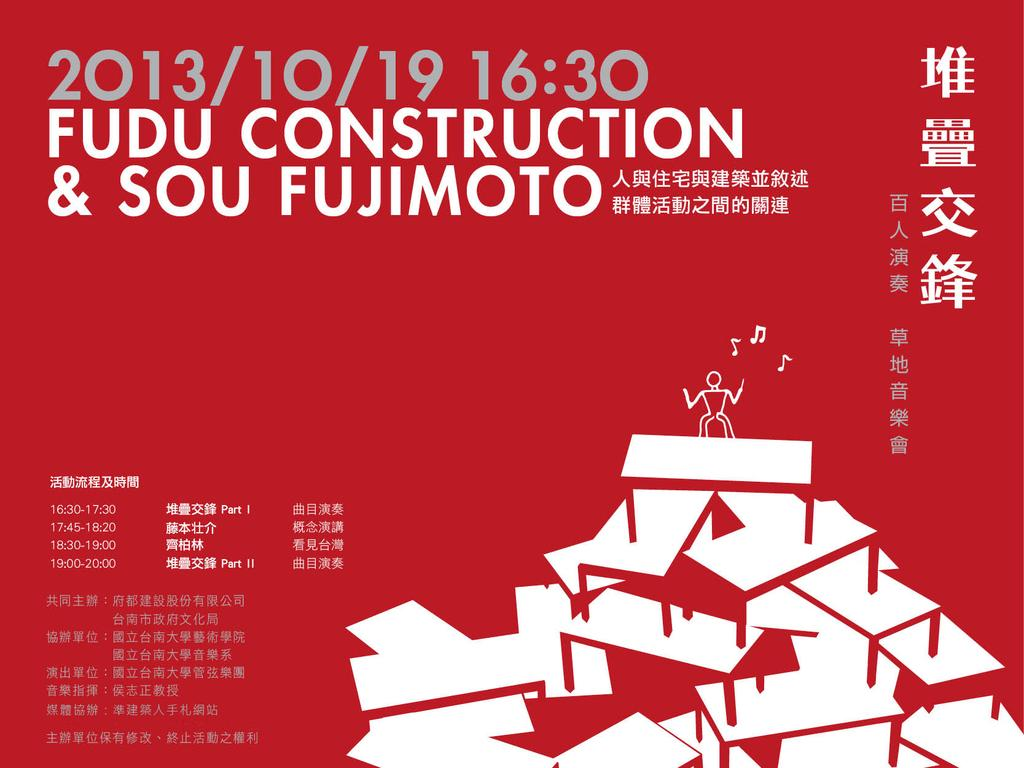<image>
Give a short and clear explanation of the subsequent image. Fudu construction and sou fujimoto that is written in china 